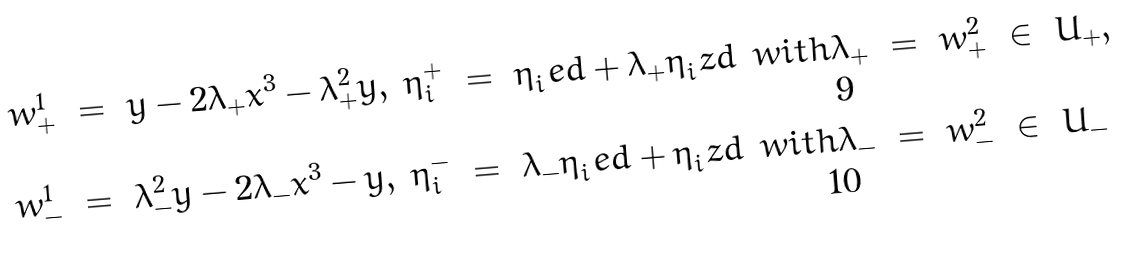<formula> <loc_0><loc_0><loc_500><loc_500>w _ { + } ^ { 1 } & \ = \ y - 2 \lambda _ { + } x ^ { 3 } - \lambda _ { + } ^ { 2 } \bar { y } , & \eta _ { i } ^ { + } & \ = \ \eta _ { i } ^ { \ } e d + \lambda _ { + } \eta _ { i } ^ { \ } z d & & w i t h \lambda _ { + } \ = \ w _ { + } ^ { 2 } \ \in \ U _ { + } , \\ w _ { - } ^ { 1 } & \ = \ \lambda _ { - } ^ { 2 } y - 2 \lambda _ { - } x ^ { 3 } - \bar { y } , & \eta _ { i } ^ { - } & \ = \ \lambda _ { - } \eta _ { i } ^ { \ } e d + \eta _ { i } ^ { \ } z d & & w i t h \lambda _ { - } \ = \ w _ { - } ^ { 2 } \ \in \ U _ { - }</formula> 